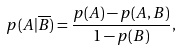Convert formula to latex. <formula><loc_0><loc_0><loc_500><loc_500>p ( A | \overline { B } ) = \frac { p ( A ) - p ( A , B ) } { 1 - p ( B ) } ,</formula> 